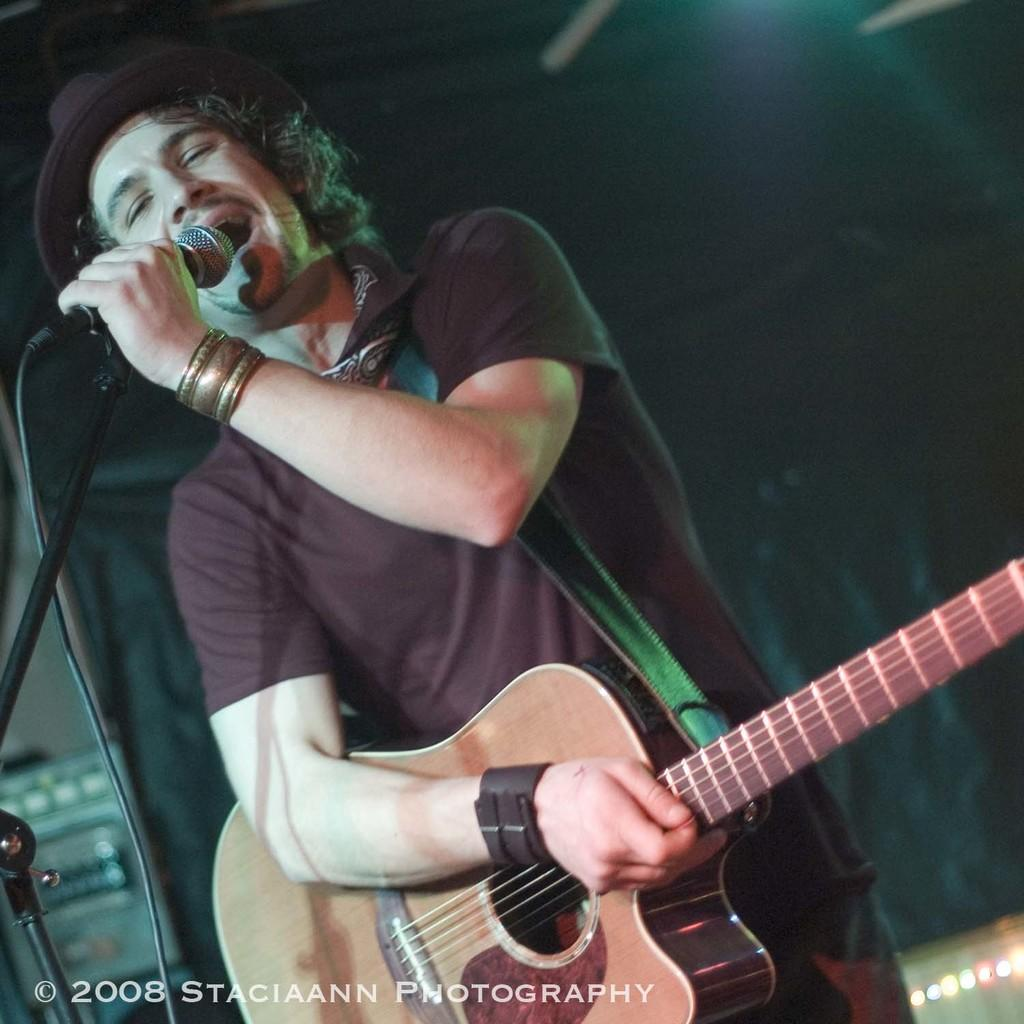What is the man in the image wearing on his upper body? The man is wearing a maroon T-shirt. What accessory is the man wearing on his head? The man is wearing a hat. What activity is the man engaged in? The man is singing. What tools is the man using while singing? The man is holding a microphone and a guitar. What can be seen in the background of the image? There is a black curtain in the background. What type of stew can be smelled in the image? There is no mention of any stew or scent in the image; it primarily features a man singing with a guitar and microphone. 